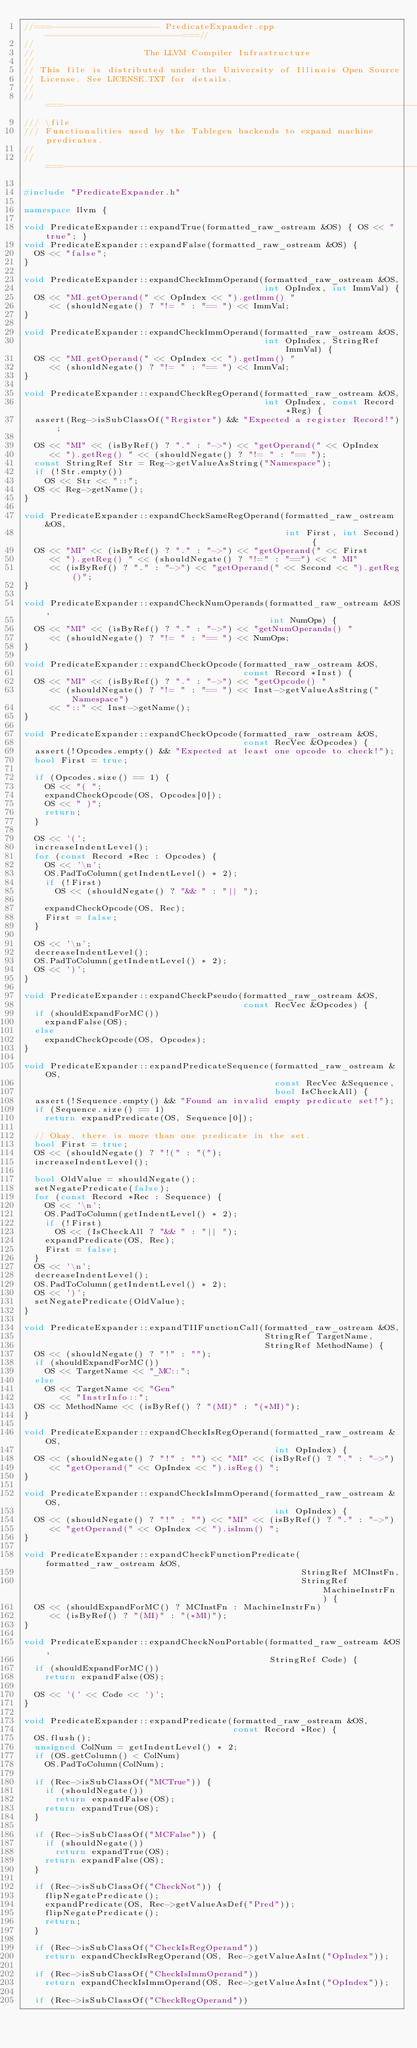<code> <loc_0><loc_0><loc_500><loc_500><_C++_>//===--------------------- PredicateExpander.cpp --------------------------===//
//
//                     The LLVM Compiler Infrastructure
//
// This file is distributed under the University of Illinois Open Source
// License. See LICENSE.TXT for details.
//
//===----------------------------------------------------------------------===//
/// \file
/// Functionalities used by the Tablegen backends to expand machine predicates.
//
//===----------------------------------------------------------------------===//

#include "PredicateExpander.h"

namespace llvm {

void PredicateExpander::expandTrue(formatted_raw_ostream &OS) { OS << "true"; }
void PredicateExpander::expandFalse(formatted_raw_ostream &OS) {
  OS << "false";
}

void PredicateExpander::expandCheckImmOperand(formatted_raw_ostream &OS,
                                              int OpIndex, int ImmVal) {
  OS << "MI.getOperand(" << OpIndex << ").getImm() "
     << (shouldNegate() ? "!= " : "== ") << ImmVal;
}

void PredicateExpander::expandCheckImmOperand(formatted_raw_ostream &OS,
                                              int OpIndex, StringRef ImmVal) {
  OS << "MI.getOperand(" << OpIndex << ").getImm() "
     << (shouldNegate() ? "!= " : "== ") << ImmVal;
}

void PredicateExpander::expandCheckRegOperand(formatted_raw_ostream &OS,
                                              int OpIndex, const Record *Reg) {
  assert(Reg->isSubClassOf("Register") && "Expected a register Record!");

  OS << "MI" << (isByRef() ? "." : "->") << "getOperand(" << OpIndex
     << ").getReg() " << (shouldNegate() ? "!= " : "== ");
  const StringRef Str = Reg->getValueAsString("Namespace");
  if (!Str.empty())
    OS << Str << "::";
  OS << Reg->getName();
}

void PredicateExpander::expandCheckSameRegOperand(formatted_raw_ostream &OS,
                                                  int First, int Second) {
  OS << "MI" << (isByRef() ? "." : "->") << "getOperand(" << First
     << ").getReg() " << (shouldNegate() ? "!=" : "==") << " MI"
     << (isByRef() ? "." : "->") << "getOperand(" << Second << ").getReg()";
}

void PredicateExpander::expandCheckNumOperands(formatted_raw_ostream &OS,
                                               int NumOps) {
  OS << "MI" << (isByRef() ? "." : "->") << "getNumOperands() "
     << (shouldNegate() ? "!= " : "== ") << NumOps;
}

void PredicateExpander::expandCheckOpcode(formatted_raw_ostream &OS,
                                          const Record *Inst) {
  OS << "MI" << (isByRef() ? "." : "->") << "getOpcode() "
     << (shouldNegate() ? "!= " : "== ") << Inst->getValueAsString("Namespace")
     << "::" << Inst->getName();
}

void PredicateExpander::expandCheckOpcode(formatted_raw_ostream &OS,
                                          const RecVec &Opcodes) {
  assert(!Opcodes.empty() && "Expected at least one opcode to check!");
  bool First = true;

  if (Opcodes.size() == 1) {
    OS << "( ";
    expandCheckOpcode(OS, Opcodes[0]);
    OS << " )";
    return;
  }

  OS << '(';
  increaseIndentLevel();
  for (const Record *Rec : Opcodes) {
    OS << '\n';
    OS.PadToColumn(getIndentLevel() * 2);
    if (!First)
      OS << (shouldNegate() ? "&& " : "|| ");

    expandCheckOpcode(OS, Rec);
    First = false;
  }

  OS << '\n';
  decreaseIndentLevel();
  OS.PadToColumn(getIndentLevel() * 2);
  OS << ')';
}

void PredicateExpander::expandCheckPseudo(formatted_raw_ostream &OS,
                                          const RecVec &Opcodes) {
  if (shouldExpandForMC())
    expandFalse(OS);
  else
    expandCheckOpcode(OS, Opcodes);
}

void PredicateExpander::expandPredicateSequence(formatted_raw_ostream &OS,
                                                const RecVec &Sequence,
                                                bool IsCheckAll) {
  assert(!Sequence.empty() && "Found an invalid empty predicate set!");
  if (Sequence.size() == 1)
    return expandPredicate(OS, Sequence[0]);

  // Okay, there is more than one predicate in the set.
  bool First = true;
  OS << (shouldNegate() ? "!(" : "(");
  increaseIndentLevel();

  bool OldValue = shouldNegate();
  setNegatePredicate(false);
  for (const Record *Rec : Sequence) {
    OS << '\n';
    OS.PadToColumn(getIndentLevel() * 2);
    if (!First)
      OS << (IsCheckAll ? "&& " : "|| ");
    expandPredicate(OS, Rec);
    First = false;
  }
  OS << '\n';
  decreaseIndentLevel();
  OS.PadToColumn(getIndentLevel() * 2);
  OS << ')';
  setNegatePredicate(OldValue);
}

void PredicateExpander::expandTIIFunctionCall(formatted_raw_ostream &OS,
                                              StringRef TargetName,
                                              StringRef MethodName) {
  OS << (shouldNegate() ? "!" : "");
  if (shouldExpandForMC())
    OS << TargetName << "_MC::";
  else
    OS << TargetName << "Gen"
       << "InstrInfo::";
  OS << MethodName << (isByRef() ? "(MI)" : "(*MI)");
}

void PredicateExpander::expandCheckIsRegOperand(formatted_raw_ostream &OS,
                                                int OpIndex) {
  OS << (shouldNegate() ? "!" : "") << "MI" << (isByRef() ? "." : "->")
     << "getOperand(" << OpIndex << ").isReg() ";
}

void PredicateExpander::expandCheckIsImmOperand(formatted_raw_ostream &OS,
                                                int OpIndex) {
  OS << (shouldNegate() ? "!" : "") << "MI" << (isByRef() ? "." : "->")
     << "getOperand(" << OpIndex << ").isImm() ";
}

void PredicateExpander::expandCheckFunctionPredicate(formatted_raw_ostream &OS,
                                                     StringRef MCInstFn,
                                                     StringRef MachineInstrFn) {
  OS << (shouldExpandForMC() ? MCInstFn : MachineInstrFn)
     << (isByRef() ? "(MI)" : "(*MI)");
}

void PredicateExpander::expandCheckNonPortable(formatted_raw_ostream &OS,
                                               StringRef Code) {
  if (shouldExpandForMC())
    return expandFalse(OS);

  OS << '(' << Code << ')';
}

void PredicateExpander::expandPredicate(formatted_raw_ostream &OS,
                                        const Record *Rec) {
  OS.flush();
  unsigned ColNum = getIndentLevel() * 2;
  if (OS.getColumn() < ColNum)
    OS.PadToColumn(ColNum);

  if (Rec->isSubClassOf("MCTrue")) {
    if (shouldNegate())
      return expandFalse(OS);
    return expandTrue(OS);
  }

  if (Rec->isSubClassOf("MCFalse")) {
    if (shouldNegate())
      return expandTrue(OS);
    return expandFalse(OS);
  }

  if (Rec->isSubClassOf("CheckNot")) {
    flipNegatePredicate();
    expandPredicate(OS, Rec->getValueAsDef("Pred"));
    flipNegatePredicate();
    return;
  }

  if (Rec->isSubClassOf("CheckIsRegOperand"))
    return expandCheckIsRegOperand(OS, Rec->getValueAsInt("OpIndex"));

  if (Rec->isSubClassOf("CheckIsImmOperand"))
    return expandCheckIsImmOperand(OS, Rec->getValueAsInt("OpIndex"));

  if (Rec->isSubClassOf("CheckRegOperand"))</code> 